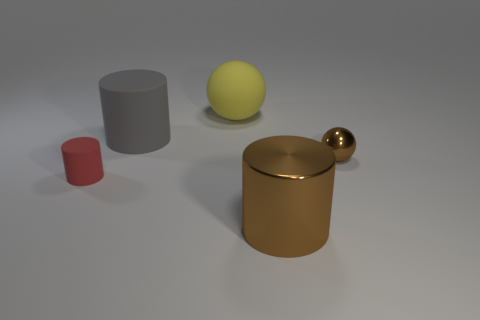Subtract all red cylinders. How many cylinders are left? 2 Add 4 big brown objects. How many objects exist? 9 Subtract 1 cylinders. How many cylinders are left? 2 Subtract all cylinders. How many objects are left? 2 Subtract all blue cylinders. Subtract all cyan blocks. How many cylinders are left? 3 Subtract 0 blue cylinders. How many objects are left? 5 Subtract all big brown spheres. Subtract all brown objects. How many objects are left? 3 Add 3 tiny brown shiny things. How many tiny brown shiny things are left? 4 Add 4 brown cylinders. How many brown cylinders exist? 5 